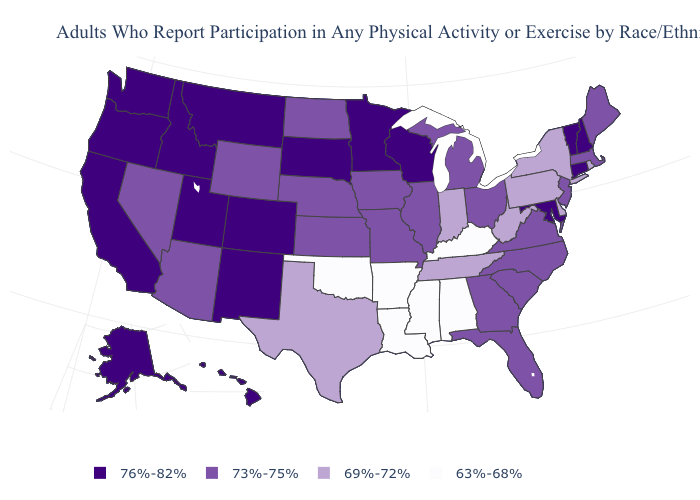Name the states that have a value in the range 69%-72%?
Concise answer only. Delaware, Indiana, New York, Pennsylvania, Rhode Island, Tennessee, Texas, West Virginia. What is the value of Florida?
Quick response, please. 73%-75%. Does Alaska have a lower value than Delaware?
Give a very brief answer. No. Among the states that border Arizona , which have the highest value?
Give a very brief answer. California, Colorado, New Mexico, Utah. How many symbols are there in the legend?
Quick response, please. 4. How many symbols are there in the legend?
Short answer required. 4. Name the states that have a value in the range 73%-75%?
Give a very brief answer. Arizona, Florida, Georgia, Illinois, Iowa, Kansas, Maine, Massachusetts, Michigan, Missouri, Nebraska, Nevada, New Jersey, North Carolina, North Dakota, Ohio, South Carolina, Virginia, Wyoming. Does Ohio have the same value as South Carolina?
Answer briefly. Yes. Among the states that border Nebraska , does Iowa have the lowest value?
Be succinct. Yes. What is the highest value in states that border Iowa?
Be succinct. 76%-82%. Name the states that have a value in the range 69%-72%?
Quick response, please. Delaware, Indiana, New York, Pennsylvania, Rhode Island, Tennessee, Texas, West Virginia. What is the highest value in the USA?
Answer briefly. 76%-82%. What is the value of Oregon?
Write a very short answer. 76%-82%. What is the highest value in states that border Indiana?
Write a very short answer. 73%-75%. What is the lowest value in the USA?
Answer briefly. 63%-68%. 